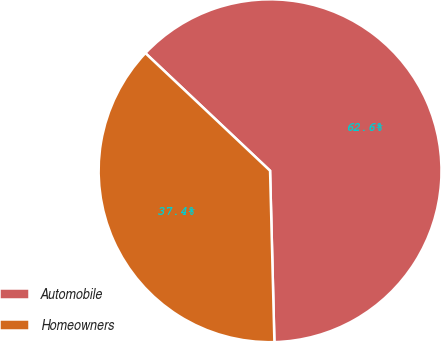Convert chart to OTSL. <chart><loc_0><loc_0><loc_500><loc_500><pie_chart><fcel>Automobile<fcel>Homeowners<nl><fcel>62.56%<fcel>37.44%<nl></chart> 